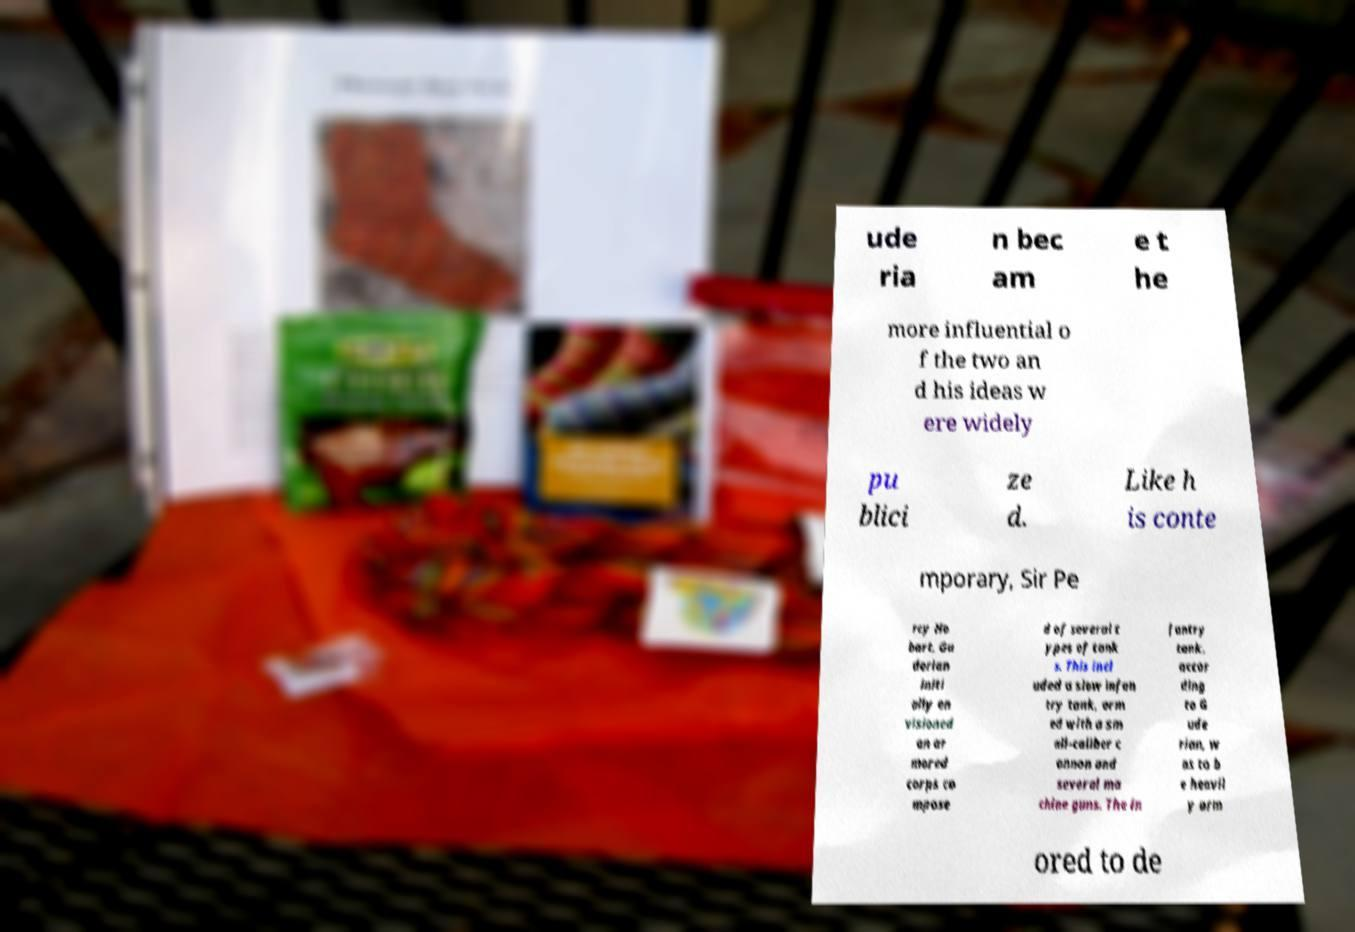Please identify and transcribe the text found in this image. ude ria n bec am e t he more influential o f the two an d his ideas w ere widely pu blici ze d. Like h is conte mporary, Sir Pe rcy Ho bart, Gu derian initi ally en visioned an ar mored corps co mpose d of several t ypes of tank s. This incl uded a slow infan try tank, arm ed with a sm all-caliber c annon and several ma chine guns. The in fantry tank, accor ding to G ude rian, w as to b e heavil y arm ored to de 